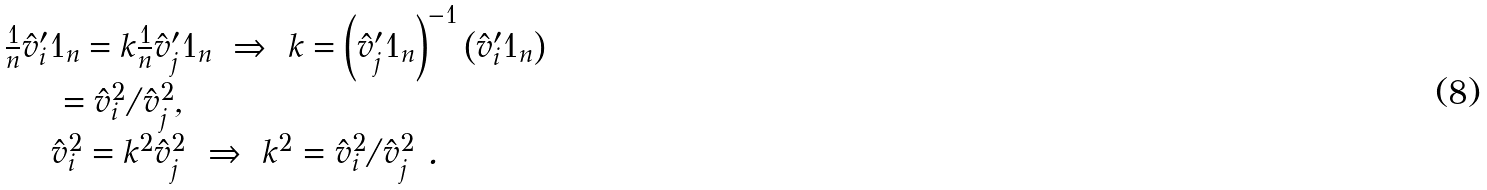Convert formula to latex. <formula><loc_0><loc_0><loc_500><loc_500>\begin{array} { l l l l } & \frac { 1 } { n } \hat { v } _ { i } ^ { \prime } 1 _ { n } = k \frac { 1 } { n } \hat { v } _ { j } ^ { \prime } 1 _ { n } \ \Rightarrow \ k = \left ( \hat { v } _ { j } ^ { \prime } 1 _ { n } \right ) ^ { - 1 } \left ( \hat { v } _ { i } ^ { \prime } 1 _ { n } \right ) \\ & \quad \ \ = \hat { v } _ { i } ^ { 2 } / \hat { v } _ { j } ^ { 2 } , \\ & \quad \ \hat { v } _ { i } ^ { 2 } = k ^ { 2 } \hat { v } _ { j } ^ { 2 } \ \Rightarrow \ k ^ { 2 } = \hat { v } _ { i } ^ { 2 } / \hat { v } _ { j } ^ { 2 } \ . \end{array}</formula> 